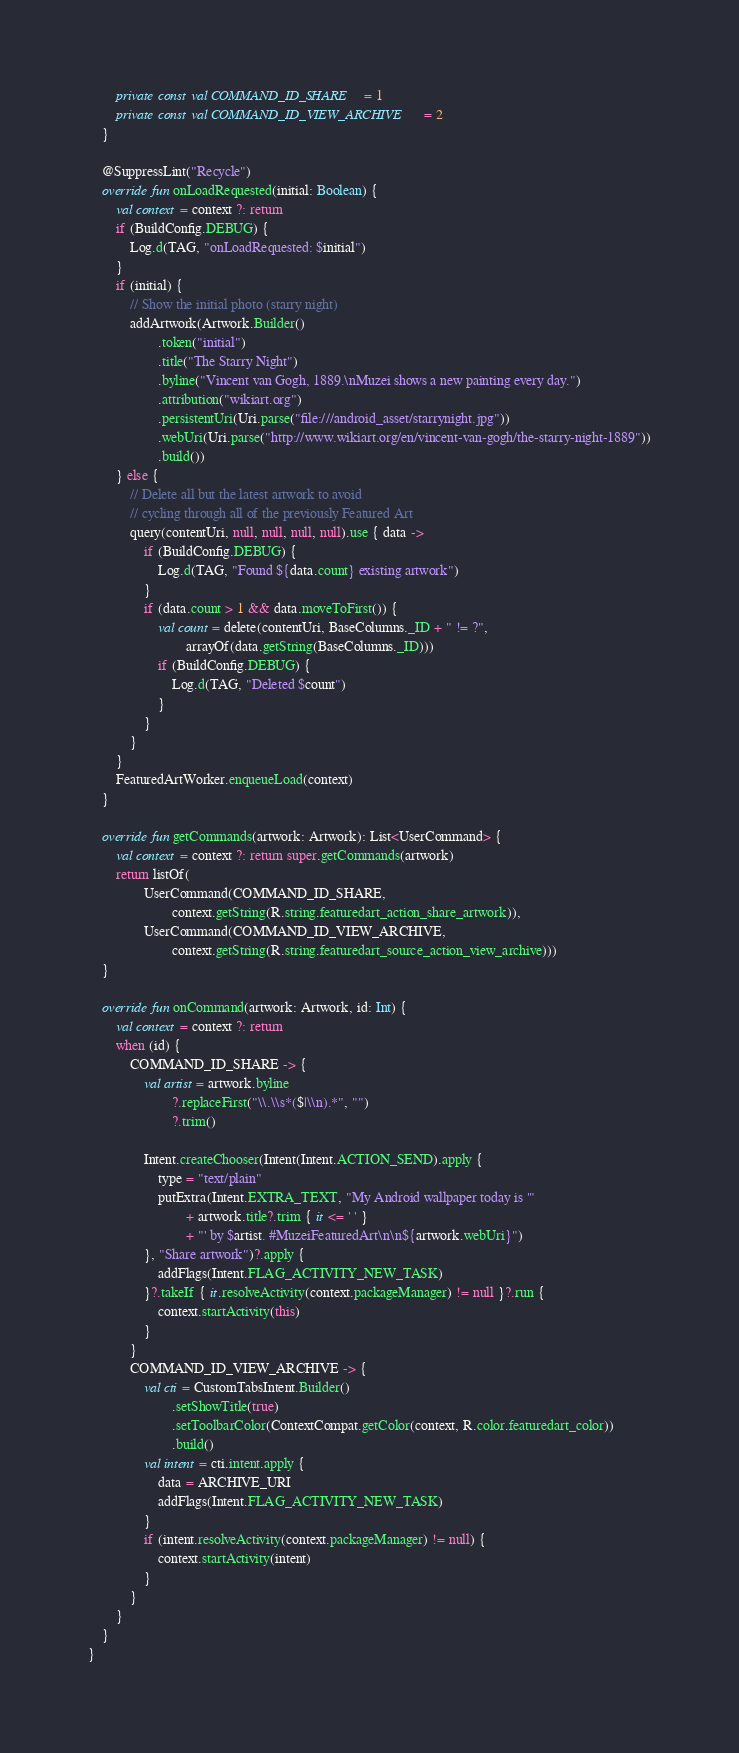Convert code to text. <code><loc_0><loc_0><loc_500><loc_500><_Kotlin_>        private const val COMMAND_ID_SHARE = 1
        private const val COMMAND_ID_VIEW_ARCHIVE = 2
    }

    @SuppressLint("Recycle")
    override fun onLoadRequested(initial: Boolean) {
        val context = context ?: return
        if (BuildConfig.DEBUG) {
            Log.d(TAG, "onLoadRequested: $initial")
        }
        if (initial) {
            // Show the initial photo (starry night)
            addArtwork(Artwork.Builder()
                    .token("initial")
                    .title("The Starry Night")
                    .byline("Vincent van Gogh, 1889.\nMuzei shows a new painting every day.")
                    .attribution("wikiart.org")
                    .persistentUri(Uri.parse("file:///android_asset/starrynight.jpg"))
                    .webUri(Uri.parse("http://www.wikiart.org/en/vincent-van-gogh/the-starry-night-1889"))
                    .build())
        } else {
            // Delete all but the latest artwork to avoid
            // cycling through all of the previously Featured Art
            query(contentUri, null, null, null, null).use { data ->
                if (BuildConfig.DEBUG) {
                    Log.d(TAG, "Found ${data.count} existing artwork")
                }
                if (data.count > 1 && data.moveToFirst()) {
                    val count = delete(contentUri, BaseColumns._ID + " != ?",
                            arrayOf(data.getString(BaseColumns._ID)))
                    if (BuildConfig.DEBUG) {
                        Log.d(TAG, "Deleted $count")
                    }
                }
            }
        }
        FeaturedArtWorker.enqueueLoad(context)
    }

    override fun getCommands(artwork: Artwork): List<UserCommand> {
        val context = context ?: return super.getCommands(artwork)
        return listOf(
                UserCommand(COMMAND_ID_SHARE,
                        context.getString(R.string.featuredart_action_share_artwork)),
                UserCommand(COMMAND_ID_VIEW_ARCHIVE,
                        context.getString(R.string.featuredart_source_action_view_archive)))
    }

    override fun onCommand(artwork: Artwork, id: Int) {
        val context = context ?: return
        when (id) {
            COMMAND_ID_SHARE -> {
                val artist = artwork.byline
                        ?.replaceFirst("\\.\\s*($|\\n).*", "")
                        ?.trim()

                Intent.createChooser(Intent(Intent.ACTION_SEND).apply {
                    type = "text/plain"
                    putExtra(Intent.EXTRA_TEXT, "My Android wallpaper today is '"
                            + artwork.title?.trim { it <= ' ' }
                            + "' by $artist. #MuzeiFeaturedArt\n\n${artwork.webUri}")
                }, "Share artwork")?.apply {
                    addFlags(Intent.FLAG_ACTIVITY_NEW_TASK)
                }?.takeIf { it.resolveActivity(context.packageManager) != null }?.run {
                    context.startActivity(this)
                }
            }
            COMMAND_ID_VIEW_ARCHIVE -> {
                val cti = CustomTabsIntent.Builder()
                        .setShowTitle(true)
                        .setToolbarColor(ContextCompat.getColor(context, R.color.featuredart_color))
                        .build()
                val intent = cti.intent.apply {
                    data = ARCHIVE_URI
                    addFlags(Intent.FLAG_ACTIVITY_NEW_TASK)
                }
                if (intent.resolveActivity(context.packageManager) != null) {
                    context.startActivity(intent)
                }
            }
        }
    }
}
</code> 